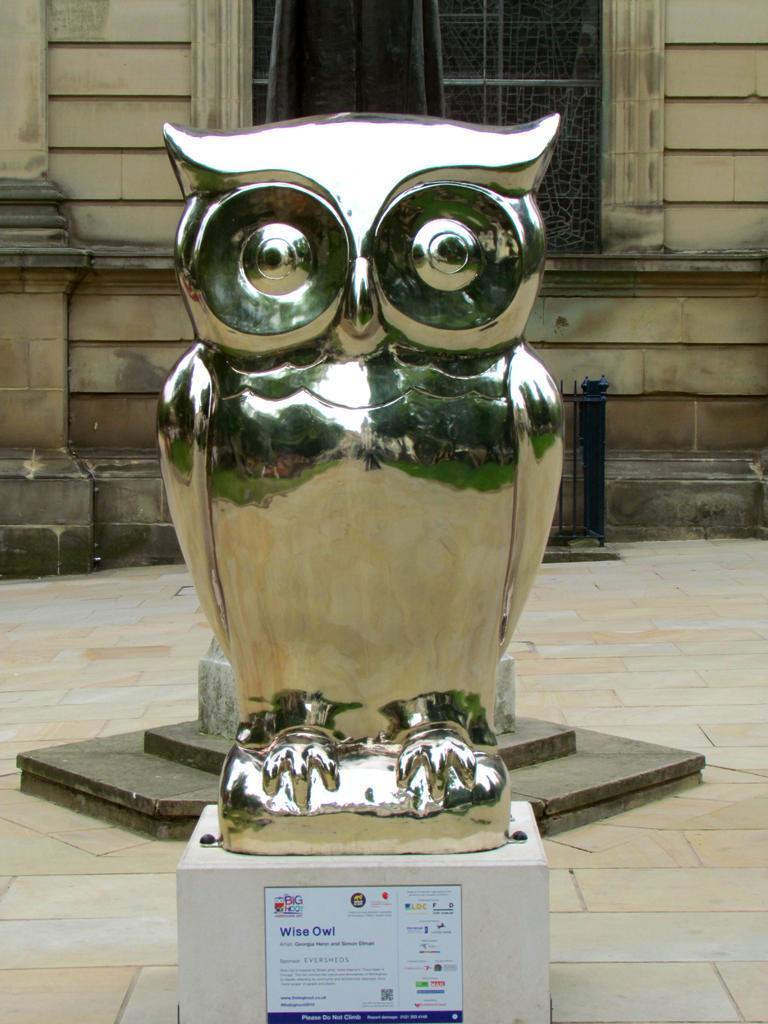Could you give a brief overview of what you see in this image? In this image I can see a statue in silver color, background I can see the building in brown color and I can also see a window. 